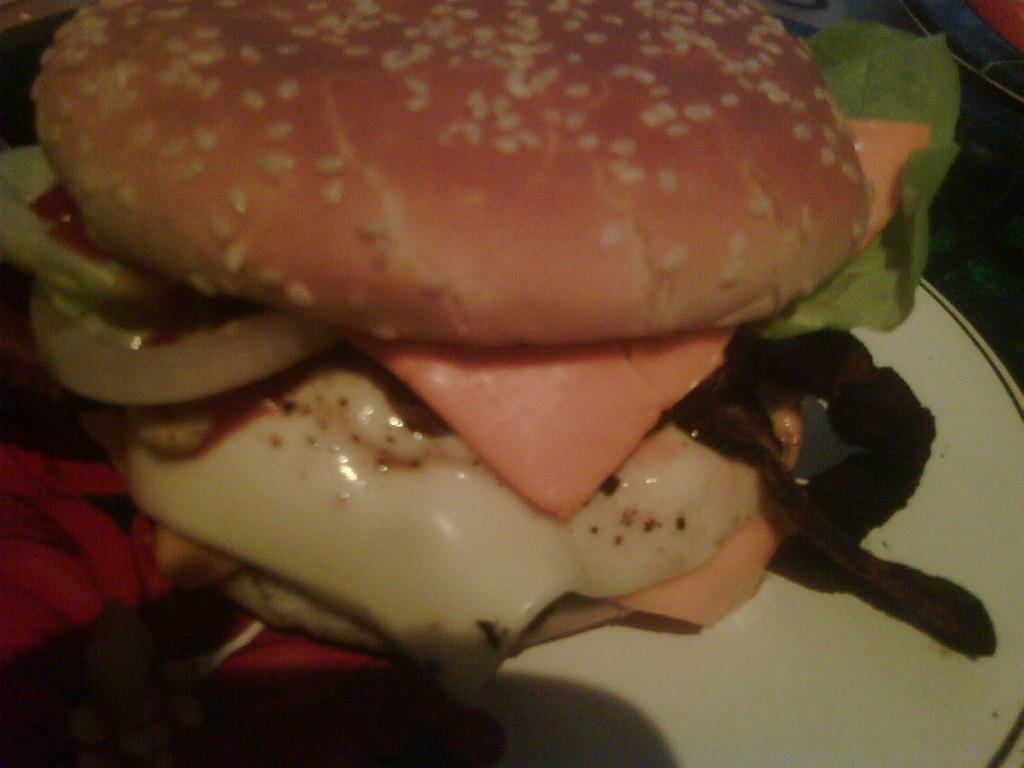What type of food can be seen in the image? The image contains food, but the specific type is not mentioned in the facts. What colors are present in the food? The food has brown, orange, cream, and black colors. How is the food arranged in the image? The food is in a plate. What colors are present in the plate? The plate is white and black in color. How many cows are visible in the image? There are no cows present in the image. Is the food being rained on in the image? There is no mention of rain in the image, and it is not possible to determine the weather conditions from the provided facts. 